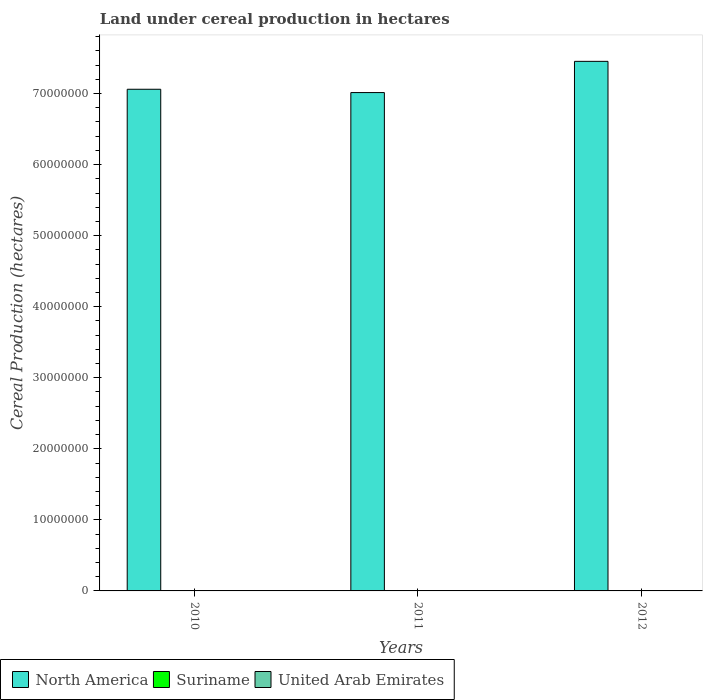How many groups of bars are there?
Your response must be concise. 3. Are the number of bars per tick equal to the number of legend labels?
Provide a succinct answer. Yes. Are the number of bars on each tick of the X-axis equal?
Your answer should be very brief. Yes. How many bars are there on the 2nd tick from the left?
Make the answer very short. 3. In how many cases, is the number of bars for a given year not equal to the number of legend labels?
Ensure brevity in your answer.  0. What is the land under cereal production in United Arab Emirates in 2011?
Provide a succinct answer. 1809. Across all years, what is the maximum land under cereal production in United Arab Emirates?
Offer a terse response. 1832. Across all years, what is the minimum land under cereal production in Suriname?
Your answer should be compact. 5.14e+04. What is the total land under cereal production in North America in the graph?
Your response must be concise. 2.15e+08. What is the difference between the land under cereal production in United Arab Emirates in 2010 and that in 2011?
Your answer should be very brief. -51.8. What is the difference between the land under cereal production in Suriname in 2010 and the land under cereal production in North America in 2012?
Keep it short and to the point. -7.45e+07. What is the average land under cereal production in Suriname per year?
Offer a terse response. 5.40e+04. In the year 2010, what is the difference between the land under cereal production in North America and land under cereal production in United Arab Emirates?
Your response must be concise. 7.06e+07. What is the ratio of the land under cereal production in Suriname in 2010 to that in 2011?
Provide a short and direct response. 0.94. What is the difference between the highest and the lowest land under cereal production in Suriname?
Provide a succinct answer. 5554. In how many years, is the land under cereal production in North America greater than the average land under cereal production in North America taken over all years?
Ensure brevity in your answer.  1. What does the 3rd bar from the left in 2012 represents?
Your answer should be compact. United Arab Emirates. What does the 2nd bar from the right in 2011 represents?
Ensure brevity in your answer.  Suriname. How many years are there in the graph?
Your answer should be compact. 3. What is the difference between two consecutive major ticks on the Y-axis?
Make the answer very short. 1.00e+07. Does the graph contain grids?
Provide a short and direct response. No. Where does the legend appear in the graph?
Your answer should be very brief. Bottom left. How many legend labels are there?
Keep it short and to the point. 3. What is the title of the graph?
Offer a very short reply. Land under cereal production in hectares. Does "Croatia" appear as one of the legend labels in the graph?
Ensure brevity in your answer.  No. What is the label or title of the X-axis?
Ensure brevity in your answer.  Years. What is the label or title of the Y-axis?
Make the answer very short. Cereal Production (hectares). What is the Cereal Production (hectares) in North America in 2010?
Give a very brief answer. 7.06e+07. What is the Cereal Production (hectares) in Suriname in 2010?
Keep it short and to the point. 5.36e+04. What is the Cereal Production (hectares) in United Arab Emirates in 2010?
Offer a terse response. 1757.2. What is the Cereal Production (hectares) of North America in 2011?
Your answer should be compact. 7.01e+07. What is the Cereal Production (hectares) of Suriname in 2011?
Your answer should be very brief. 5.69e+04. What is the Cereal Production (hectares) of United Arab Emirates in 2011?
Provide a succinct answer. 1809. What is the Cereal Production (hectares) of North America in 2012?
Give a very brief answer. 7.45e+07. What is the Cereal Production (hectares) of Suriname in 2012?
Make the answer very short. 5.14e+04. What is the Cereal Production (hectares) of United Arab Emirates in 2012?
Offer a terse response. 1832. Across all years, what is the maximum Cereal Production (hectares) in North America?
Give a very brief answer. 7.45e+07. Across all years, what is the maximum Cereal Production (hectares) of Suriname?
Keep it short and to the point. 5.69e+04. Across all years, what is the maximum Cereal Production (hectares) of United Arab Emirates?
Offer a terse response. 1832. Across all years, what is the minimum Cereal Production (hectares) of North America?
Your answer should be compact. 7.01e+07. Across all years, what is the minimum Cereal Production (hectares) of Suriname?
Ensure brevity in your answer.  5.14e+04. Across all years, what is the minimum Cereal Production (hectares) in United Arab Emirates?
Make the answer very short. 1757.2. What is the total Cereal Production (hectares) in North America in the graph?
Your response must be concise. 2.15e+08. What is the total Cereal Production (hectares) of Suriname in the graph?
Offer a terse response. 1.62e+05. What is the total Cereal Production (hectares) of United Arab Emirates in the graph?
Provide a succinct answer. 5398.2. What is the difference between the Cereal Production (hectares) in North America in 2010 and that in 2011?
Ensure brevity in your answer.  4.66e+05. What is the difference between the Cereal Production (hectares) of Suriname in 2010 and that in 2011?
Offer a very short reply. -3376. What is the difference between the Cereal Production (hectares) in United Arab Emirates in 2010 and that in 2011?
Give a very brief answer. -51.8. What is the difference between the Cereal Production (hectares) in North America in 2010 and that in 2012?
Your answer should be very brief. -3.93e+06. What is the difference between the Cereal Production (hectares) of Suriname in 2010 and that in 2012?
Offer a terse response. 2178. What is the difference between the Cereal Production (hectares) of United Arab Emirates in 2010 and that in 2012?
Your answer should be compact. -74.8. What is the difference between the Cereal Production (hectares) in North America in 2011 and that in 2012?
Provide a succinct answer. -4.39e+06. What is the difference between the Cereal Production (hectares) of Suriname in 2011 and that in 2012?
Your answer should be very brief. 5554. What is the difference between the Cereal Production (hectares) in United Arab Emirates in 2011 and that in 2012?
Offer a very short reply. -23. What is the difference between the Cereal Production (hectares) of North America in 2010 and the Cereal Production (hectares) of Suriname in 2011?
Provide a succinct answer. 7.05e+07. What is the difference between the Cereal Production (hectares) of North America in 2010 and the Cereal Production (hectares) of United Arab Emirates in 2011?
Offer a very short reply. 7.06e+07. What is the difference between the Cereal Production (hectares) of Suriname in 2010 and the Cereal Production (hectares) of United Arab Emirates in 2011?
Offer a terse response. 5.18e+04. What is the difference between the Cereal Production (hectares) of North America in 2010 and the Cereal Production (hectares) of Suriname in 2012?
Keep it short and to the point. 7.06e+07. What is the difference between the Cereal Production (hectares) in North America in 2010 and the Cereal Production (hectares) in United Arab Emirates in 2012?
Offer a very short reply. 7.06e+07. What is the difference between the Cereal Production (hectares) of Suriname in 2010 and the Cereal Production (hectares) of United Arab Emirates in 2012?
Provide a short and direct response. 5.17e+04. What is the difference between the Cereal Production (hectares) in North America in 2011 and the Cereal Production (hectares) in Suriname in 2012?
Your answer should be very brief. 7.01e+07. What is the difference between the Cereal Production (hectares) of North America in 2011 and the Cereal Production (hectares) of United Arab Emirates in 2012?
Ensure brevity in your answer.  7.01e+07. What is the difference between the Cereal Production (hectares) of Suriname in 2011 and the Cereal Production (hectares) of United Arab Emirates in 2012?
Ensure brevity in your answer.  5.51e+04. What is the average Cereal Production (hectares) of North America per year?
Provide a succinct answer. 7.18e+07. What is the average Cereal Production (hectares) in Suriname per year?
Offer a terse response. 5.40e+04. What is the average Cereal Production (hectares) in United Arab Emirates per year?
Make the answer very short. 1799.4. In the year 2010, what is the difference between the Cereal Production (hectares) in North America and Cereal Production (hectares) in Suriname?
Your answer should be very brief. 7.05e+07. In the year 2010, what is the difference between the Cereal Production (hectares) of North America and Cereal Production (hectares) of United Arab Emirates?
Offer a terse response. 7.06e+07. In the year 2010, what is the difference between the Cereal Production (hectares) of Suriname and Cereal Production (hectares) of United Arab Emirates?
Provide a short and direct response. 5.18e+04. In the year 2011, what is the difference between the Cereal Production (hectares) in North America and Cereal Production (hectares) in Suriname?
Offer a very short reply. 7.01e+07. In the year 2011, what is the difference between the Cereal Production (hectares) of North America and Cereal Production (hectares) of United Arab Emirates?
Your response must be concise. 7.01e+07. In the year 2011, what is the difference between the Cereal Production (hectares) of Suriname and Cereal Production (hectares) of United Arab Emirates?
Keep it short and to the point. 5.51e+04. In the year 2012, what is the difference between the Cereal Production (hectares) in North America and Cereal Production (hectares) in Suriname?
Offer a very short reply. 7.45e+07. In the year 2012, what is the difference between the Cereal Production (hectares) of North America and Cereal Production (hectares) of United Arab Emirates?
Ensure brevity in your answer.  7.45e+07. In the year 2012, what is the difference between the Cereal Production (hectares) in Suriname and Cereal Production (hectares) in United Arab Emirates?
Your answer should be very brief. 4.96e+04. What is the ratio of the Cereal Production (hectares) in North America in 2010 to that in 2011?
Give a very brief answer. 1.01. What is the ratio of the Cereal Production (hectares) of Suriname in 2010 to that in 2011?
Your answer should be very brief. 0.94. What is the ratio of the Cereal Production (hectares) in United Arab Emirates in 2010 to that in 2011?
Provide a succinct answer. 0.97. What is the ratio of the Cereal Production (hectares) in North America in 2010 to that in 2012?
Provide a short and direct response. 0.95. What is the ratio of the Cereal Production (hectares) of Suriname in 2010 to that in 2012?
Keep it short and to the point. 1.04. What is the ratio of the Cereal Production (hectares) of United Arab Emirates in 2010 to that in 2012?
Offer a terse response. 0.96. What is the ratio of the Cereal Production (hectares) in North America in 2011 to that in 2012?
Keep it short and to the point. 0.94. What is the ratio of the Cereal Production (hectares) in Suriname in 2011 to that in 2012?
Give a very brief answer. 1.11. What is the ratio of the Cereal Production (hectares) of United Arab Emirates in 2011 to that in 2012?
Your response must be concise. 0.99. What is the difference between the highest and the second highest Cereal Production (hectares) of North America?
Ensure brevity in your answer.  3.93e+06. What is the difference between the highest and the second highest Cereal Production (hectares) in Suriname?
Offer a very short reply. 3376. What is the difference between the highest and the lowest Cereal Production (hectares) in North America?
Keep it short and to the point. 4.39e+06. What is the difference between the highest and the lowest Cereal Production (hectares) of Suriname?
Provide a succinct answer. 5554. What is the difference between the highest and the lowest Cereal Production (hectares) in United Arab Emirates?
Provide a succinct answer. 74.8. 